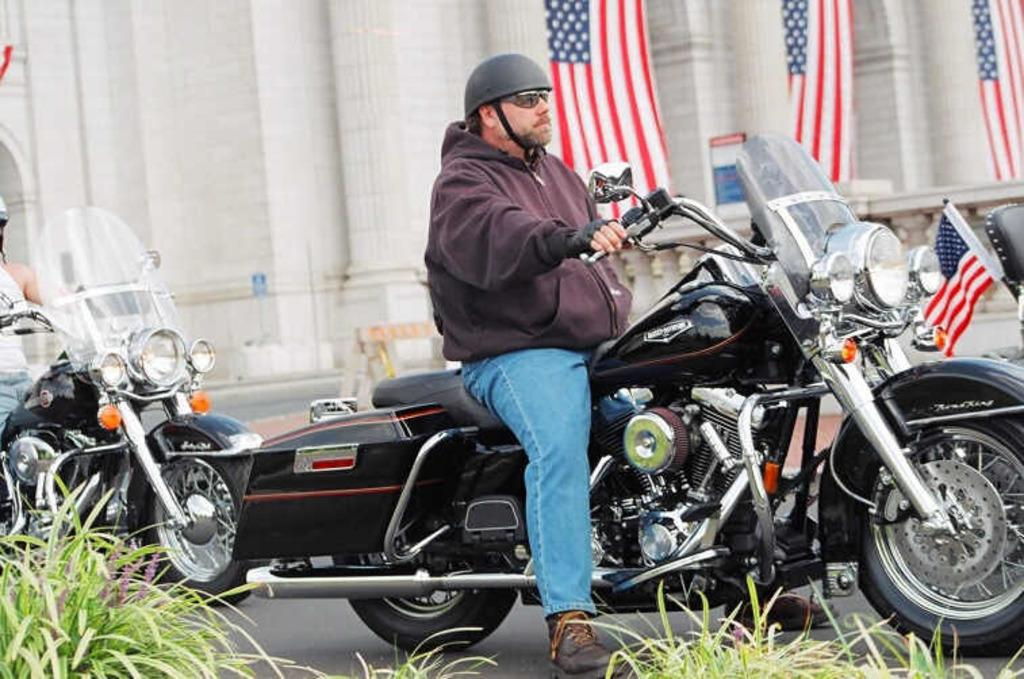What is the man in the image doing? The man is riding a bike in the image. Where is the man riding the bike? The man is on a road. Can you describe the background of the image? There is another person, grass, a flag, and a building visible in the background of the image. What type of whistle can be heard in the image? There is no whistle present in the image, so it cannot be heard. 